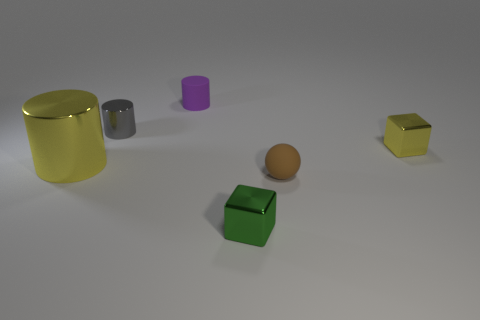Are there any patterns or textures on the objects? No, the objects in the image do not display any visible patterns or textures. They all have a matte finish with solid colors and are placed on a smooth surface. 